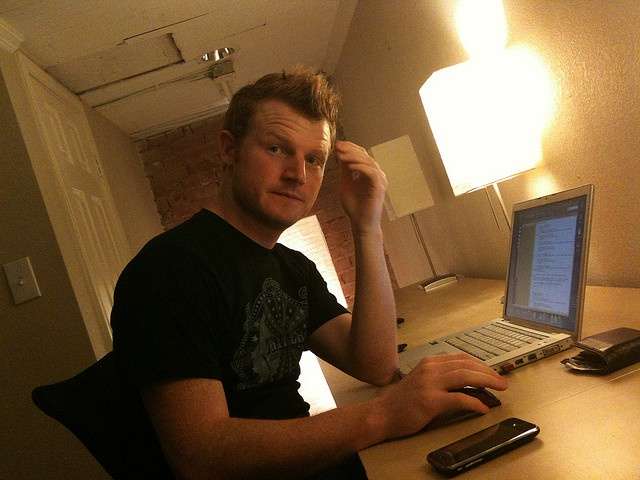Describe the objects in this image and their specific colors. I can see people in olive, black, maroon, and brown tones, dining table in olive, tan, black, and maroon tones, laptop in olive, maroon, and gray tones, chair in black and olive tones, and cell phone in olive, black, maroon, and white tones in this image. 